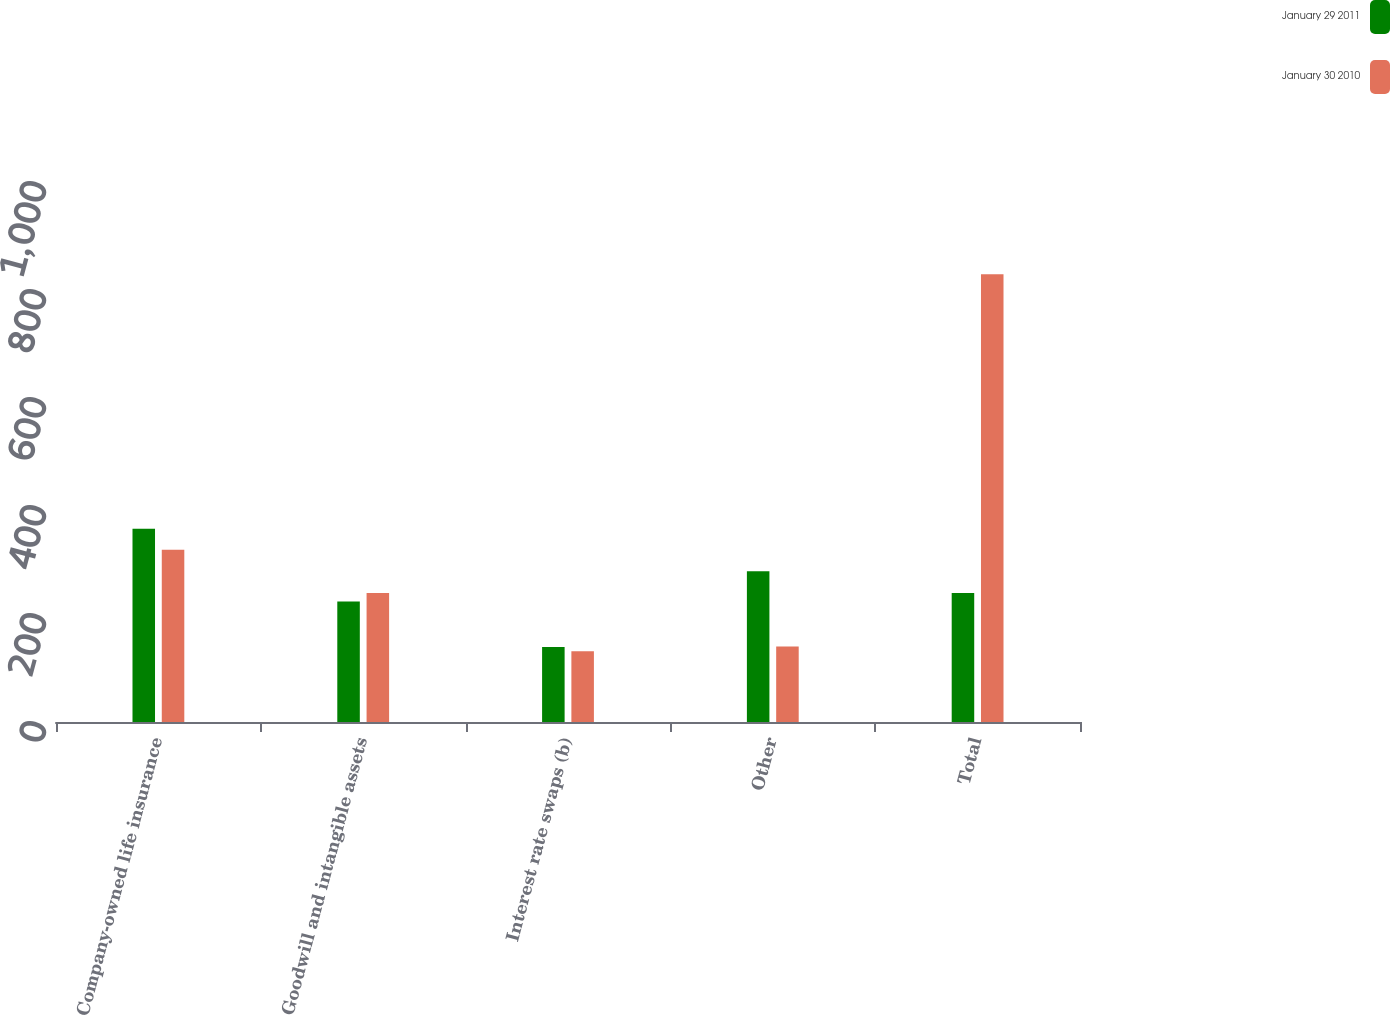Convert chart to OTSL. <chart><loc_0><loc_0><loc_500><loc_500><stacked_bar_chart><ecel><fcel>Company-owned life insurance<fcel>Goodwill and intangible assets<fcel>Interest rate swaps (b)<fcel>Other<fcel>Total<nl><fcel>January 29 2011<fcel>358<fcel>223<fcel>139<fcel>279<fcel>239<nl><fcel>January 30 2010<fcel>319<fcel>239<fcel>131<fcel>140<fcel>829<nl></chart> 